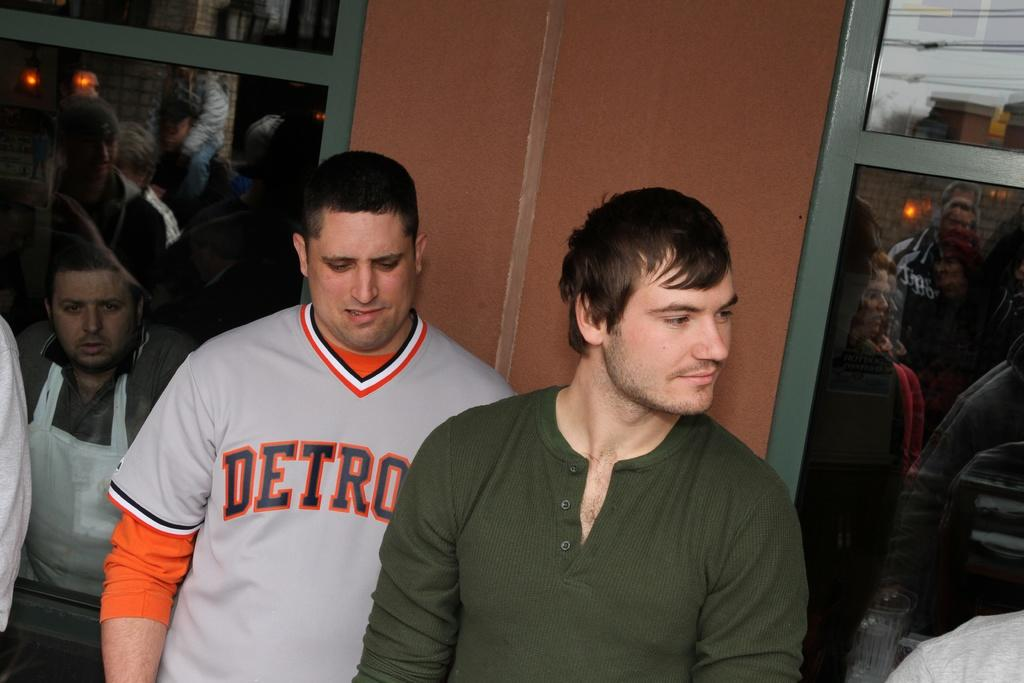<image>
Present a compact description of the photo's key features. A person wearing a Detroit team shirt is looking down. 